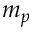Convert formula to latex. <formula><loc_0><loc_0><loc_500><loc_500>m _ { p }</formula> 